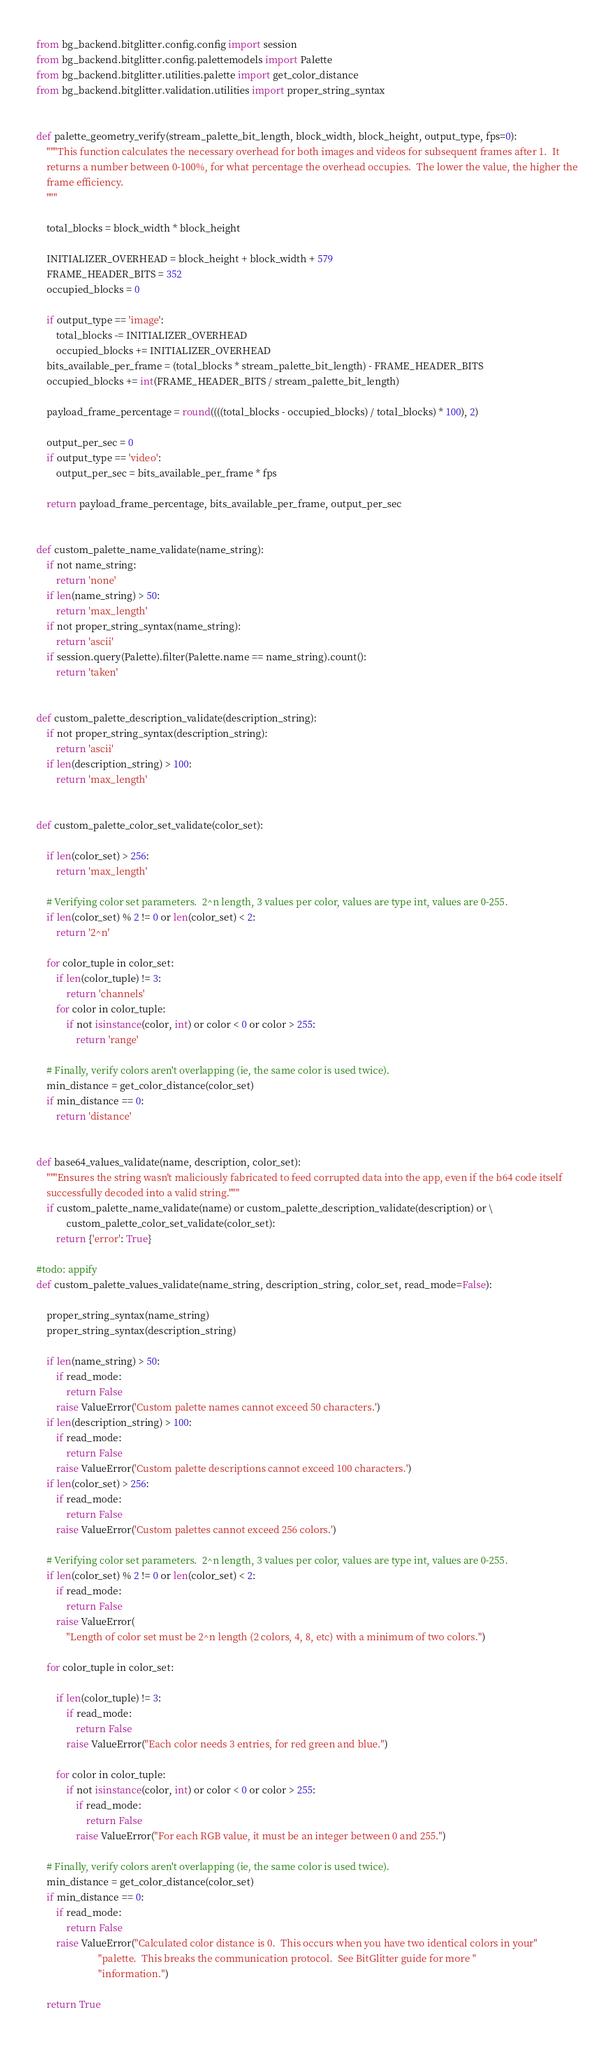<code> <loc_0><loc_0><loc_500><loc_500><_Python_>from bg_backend.bitglitter.config.config import session
from bg_backend.bitglitter.config.palettemodels import Palette
from bg_backend.bitglitter.utilities.palette import get_color_distance
from bg_backend.bitglitter.validation.utilities import proper_string_syntax


def palette_geometry_verify(stream_palette_bit_length, block_width, block_height, output_type, fps=0):
    """This function calculates the necessary overhead for both images and videos for subsequent frames after 1.  It
    returns a number between 0-100%, for what percentage the overhead occupies.  The lower the value, the higher the
    frame efficiency.
    """

    total_blocks = block_width * block_height

    INITIALIZER_OVERHEAD = block_height + block_width + 579
    FRAME_HEADER_BITS = 352
    occupied_blocks = 0

    if output_type == 'image':
        total_blocks -= INITIALIZER_OVERHEAD
        occupied_blocks += INITIALIZER_OVERHEAD
    bits_available_per_frame = (total_blocks * stream_palette_bit_length) - FRAME_HEADER_BITS
    occupied_blocks += int(FRAME_HEADER_BITS / stream_palette_bit_length)

    payload_frame_percentage = round((((total_blocks - occupied_blocks) / total_blocks) * 100), 2)

    output_per_sec = 0
    if output_type == 'video':
        output_per_sec = bits_available_per_frame * fps

    return payload_frame_percentage, bits_available_per_frame, output_per_sec


def custom_palette_name_validate(name_string):
    if not name_string:
        return 'none'
    if len(name_string) > 50:
        return 'max_length'
    if not proper_string_syntax(name_string):
        return 'ascii'
    if session.query(Palette).filter(Palette.name == name_string).count():
        return 'taken'


def custom_palette_description_validate(description_string):
    if not proper_string_syntax(description_string):
        return 'ascii'
    if len(description_string) > 100:
        return 'max_length'


def custom_palette_color_set_validate(color_set):

    if len(color_set) > 256:
        return 'max_length'

    # Verifying color set parameters.  2^n length, 3 values per color, values are type int, values are 0-255.
    if len(color_set) % 2 != 0 or len(color_set) < 2:
        return '2^n'

    for color_tuple in color_set:
        if len(color_tuple) != 3:
            return 'channels'
        for color in color_tuple:
            if not isinstance(color, int) or color < 0 or color > 255:
                return 'range'

    # Finally, verify colors aren't overlapping (ie, the same color is used twice).
    min_distance = get_color_distance(color_set)
    if min_distance == 0:
        return 'distance'


def base64_values_validate(name, description, color_set):
    """Ensures the string wasn't maliciously fabricated to feed corrupted data into the app, even if the b64 code itself
    successfully decoded into a valid string."""
    if custom_palette_name_validate(name) or custom_palette_description_validate(description) or \
            custom_palette_color_set_validate(color_set):
        return {'error': True}

#todo: appify
def custom_palette_values_validate(name_string, description_string, color_set, read_mode=False):

    proper_string_syntax(name_string)
    proper_string_syntax(description_string)

    if len(name_string) > 50:
        if read_mode:
            return False
        raise ValueError('Custom palette names cannot exceed 50 characters.')
    if len(description_string) > 100:
        if read_mode:
            return False
        raise ValueError('Custom palette descriptions cannot exceed 100 characters.')
    if len(color_set) > 256:
        if read_mode:
            return False
        raise ValueError('Custom palettes cannot exceed 256 colors.')

    # Verifying color set parameters.  2^n length, 3 values per color, values are type int, values are 0-255.
    if len(color_set) % 2 != 0 or len(color_set) < 2:
        if read_mode:
            return False
        raise ValueError(
            "Length of color set must be 2^n length (2 colors, 4, 8, etc) with a minimum of two colors.")

    for color_tuple in color_set:

        if len(color_tuple) != 3:
            if read_mode:
                return False
            raise ValueError("Each color needs 3 entries, for red green and blue.")

        for color in color_tuple:
            if not isinstance(color, int) or color < 0 or color > 255:
                if read_mode:
                    return False
                raise ValueError("For each RGB value, it must be an integer between 0 and 255.")

    # Finally, verify colors aren't overlapping (ie, the same color is used twice).
    min_distance = get_color_distance(color_set)
    if min_distance == 0:
        if read_mode:
            return False
        raise ValueError("Calculated color distance is 0.  This occurs when you have two identical colors in your"
                         "palette.  This breaks the communication protocol.  See BitGlitter guide for more "
                         "information.")

    return True
</code> 